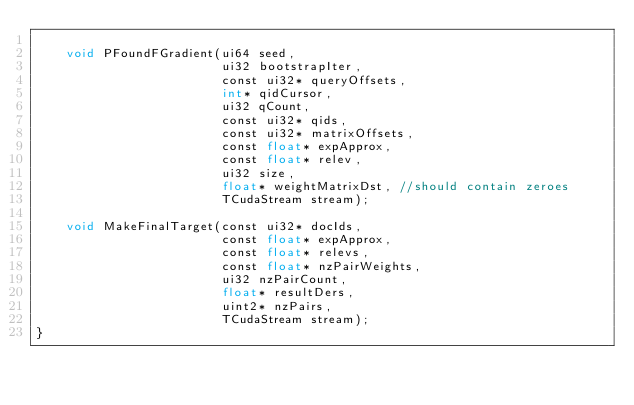<code> <loc_0><loc_0><loc_500><loc_500><_Cuda_>
    void PFoundFGradient(ui64 seed,
                         ui32 bootstrapIter,
                         const ui32* queryOffsets,
                         int* qidCursor,
                         ui32 qCount,
                         const ui32* qids,
                         const ui32* matrixOffsets,
                         const float* expApprox,
                         const float* relev,
                         ui32 size,
                         float* weightMatrixDst, //should contain zeroes
                         TCudaStream stream);

    void MakeFinalTarget(const ui32* docIds,
                         const float* expApprox,
                         const float* relevs,
                         const float* nzPairWeights,
                         ui32 nzPairCount,
                         float* resultDers,
                         uint2* nzPairs,
                         TCudaStream stream);
}
</code> 